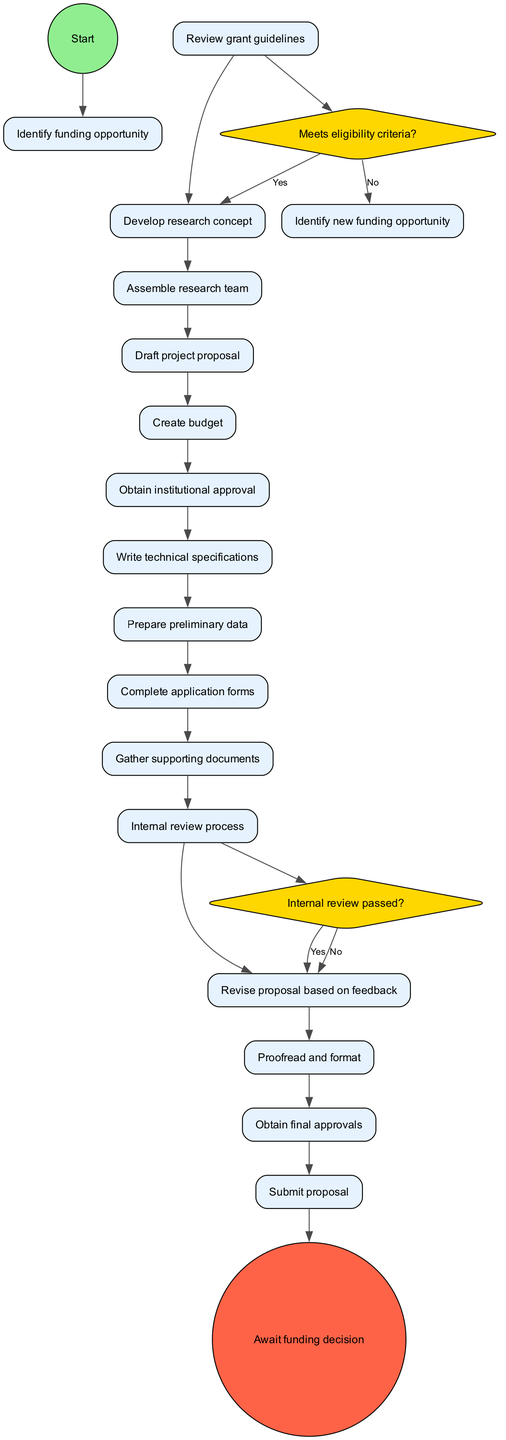What is the first activity in the sequence? The diagram starts with the node labeled "Identify funding opportunity," which indicates that this is the initial step in the sequence of activities.
Answer: Identify funding opportunity How many activities are there in total? The diagram lists a total of 15 activities, which can be counted directly from the activities mentioned in the data provided.
Answer: 15 What comes after "Draft project proposal"? The next activity following "Draft project proposal" is "Create budget," which shows the linear flow of activities as indicated in the diagram.
Answer: Create budget What is the decision point following the activity "Review grant guidelines"? The decision point after "Review grant guidelines" is "Meets eligibility criteria?", which directs the flow of the diagram based on the answer to this question.
Answer: Meets eligibility criteria? If the answer to "Internal review passed?" is "No", what is the next step? If the answer to "Internal review passed?" is "No," the next step is to "Revise proposal based on feedback," indicating that the process requires revision before proceeding.
Answer: Revise proposal based on feedback How many decision points are in the diagram? The diagram includes 2 decision points, which are explicitly listed in the decisionPoints section of the data.
Answer: 2 What is the final node in the sequence? The final node in the sequence is "Await funding decision," which signifies the conclusion of the activity sequence in the diagram.
Answer: Await funding decision Which activity requires "institutional approval"? The activity that requires "institutional approval" is "Obtain institutional approval," which is indicated as a unique activity in the flow of the diagram.
Answer: Obtain institutional approval What action occurs if eligibility criteria are not met? If eligibility criteria are not met, the action directed is to "Identify new funding opportunity," establishing a fallback step in the process.
Answer: Identify new funding opportunity How does the "Await funding decision" activity relate to the previous activity? The "Await funding decision" activity follows the last activity "Submit proposal," indicating that it is the outcome after submitting the grant proposal.
Answer: It follows "Submit proposal" 